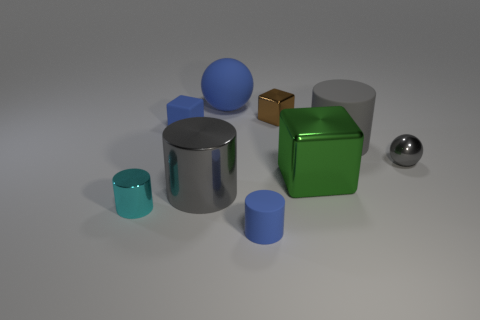The small metal block is what color? The small cube appears to be gold or a reflective brass color, which is demonstrated by its shiny surface reflecting the surrounding objects. 